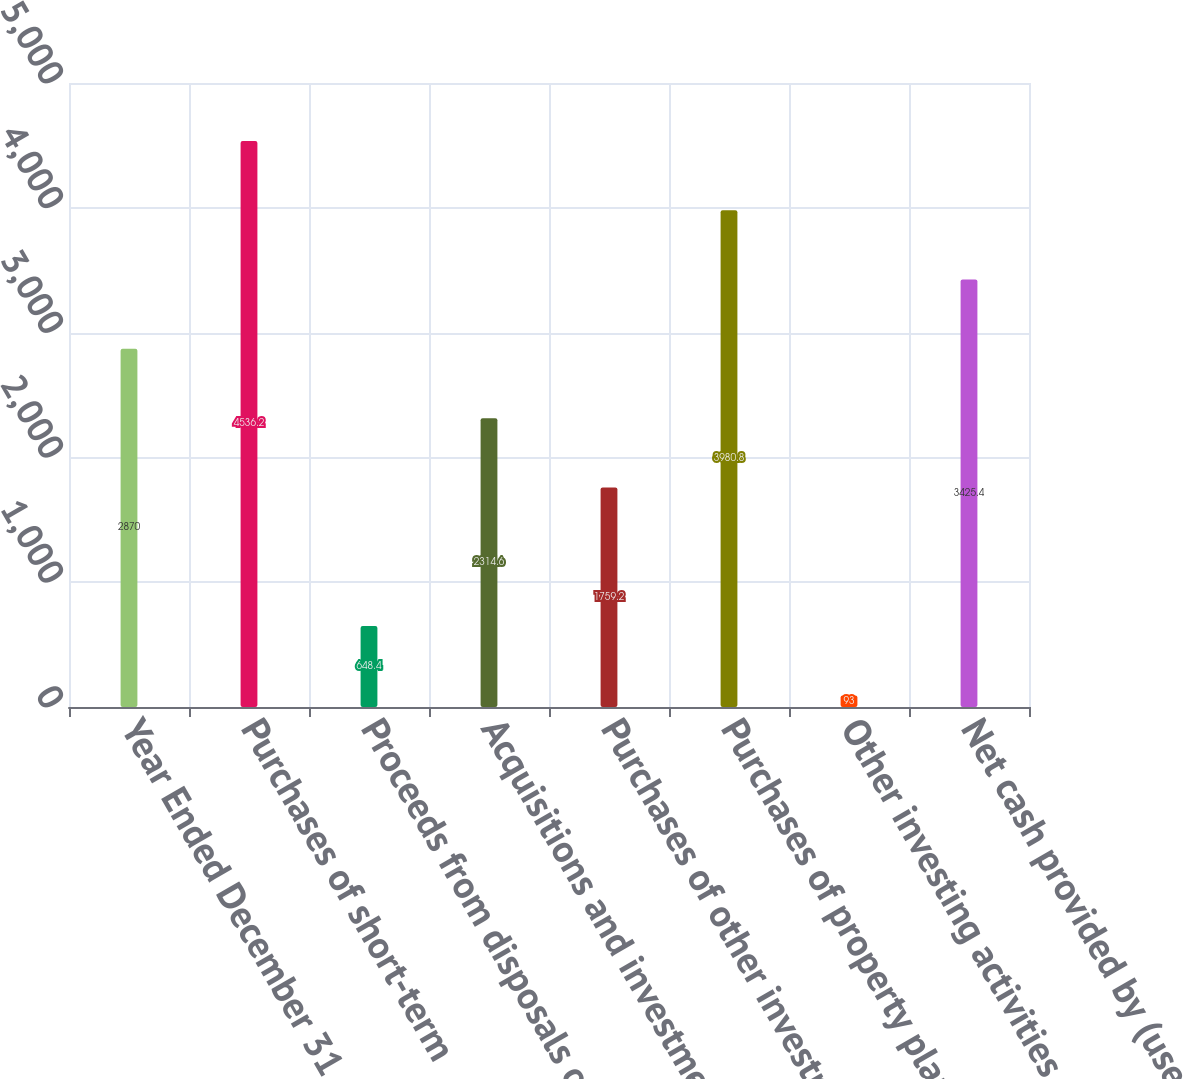Convert chart to OTSL. <chart><loc_0><loc_0><loc_500><loc_500><bar_chart><fcel>Year Ended December 31<fcel>Purchases of short-term<fcel>Proceeds from disposals of<fcel>Acquisitions and investments<fcel>Purchases of other investments<fcel>Purchases of property plant<fcel>Other investing activities<fcel>Net cash provided by (used in)<nl><fcel>2870<fcel>4536.2<fcel>648.4<fcel>2314.6<fcel>1759.2<fcel>3980.8<fcel>93<fcel>3425.4<nl></chart> 